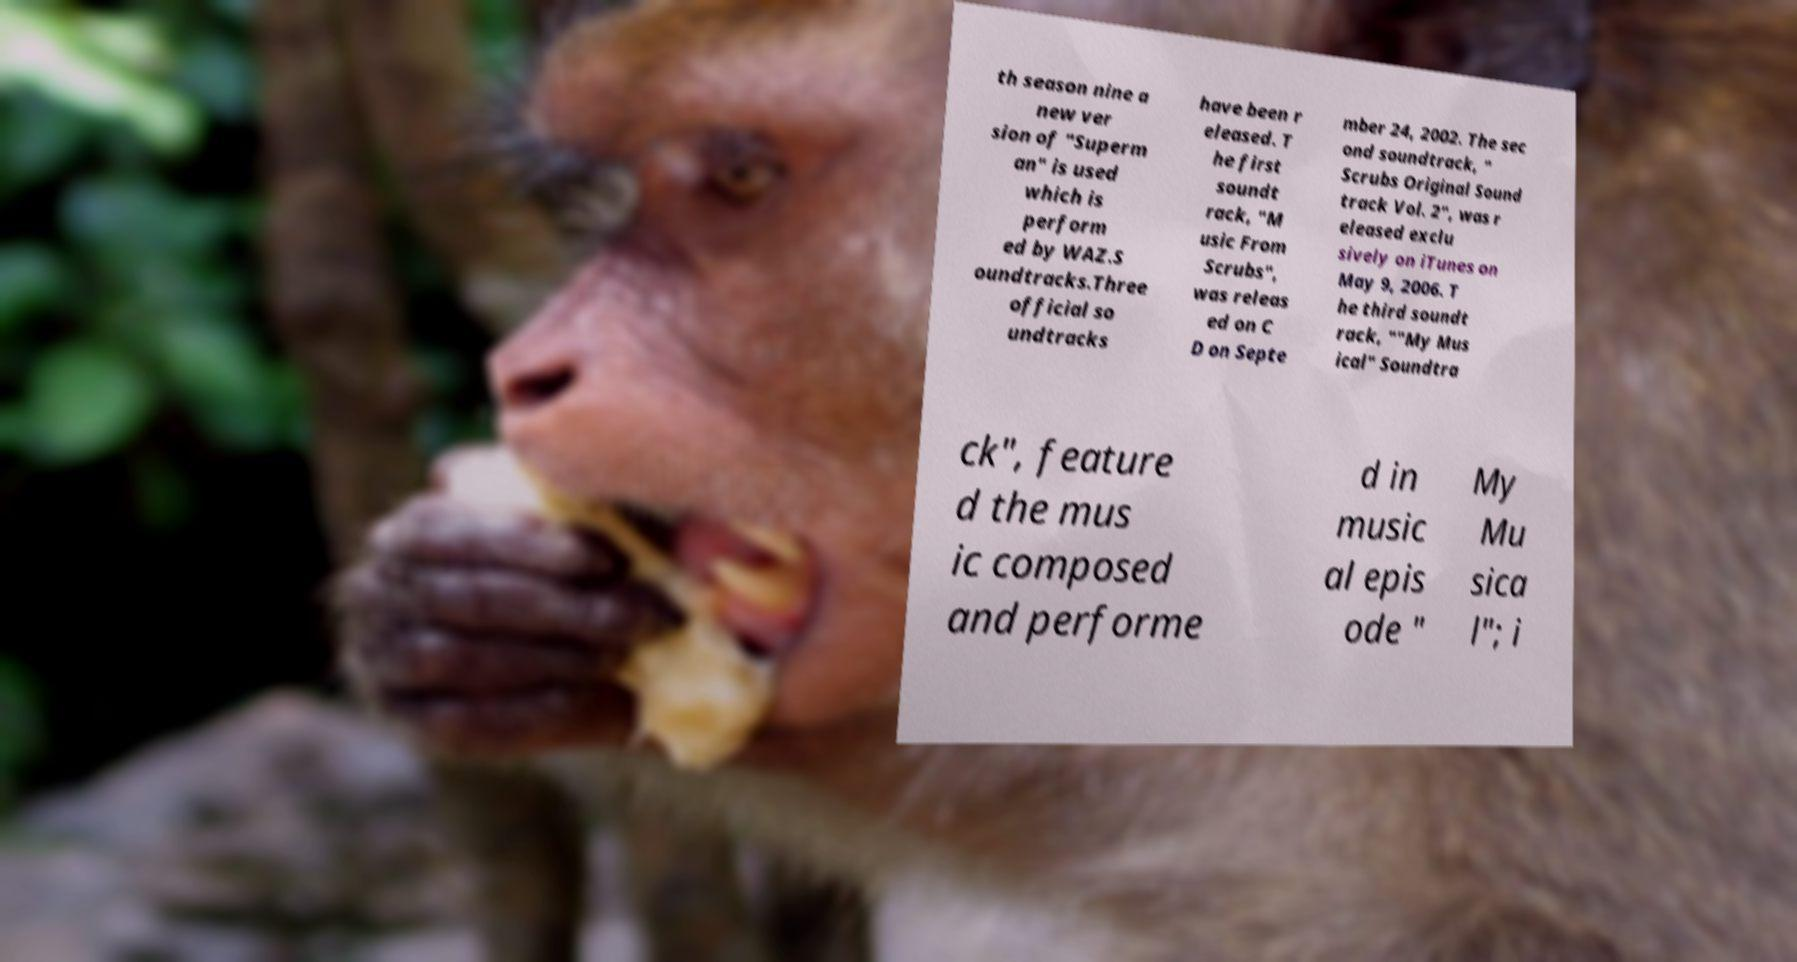Please read and relay the text visible in this image. What does it say? th season nine a new ver sion of "Superm an" is used which is perform ed by WAZ.S oundtracks.Three official so undtracks have been r eleased. T he first soundt rack, "M usic From Scrubs", was releas ed on C D on Septe mber 24, 2002. The sec ond soundtrack, " Scrubs Original Sound track Vol. 2", was r eleased exclu sively on iTunes on May 9, 2006. T he third soundt rack, ""My Mus ical" Soundtra ck", feature d the mus ic composed and performe d in music al epis ode " My Mu sica l"; i 